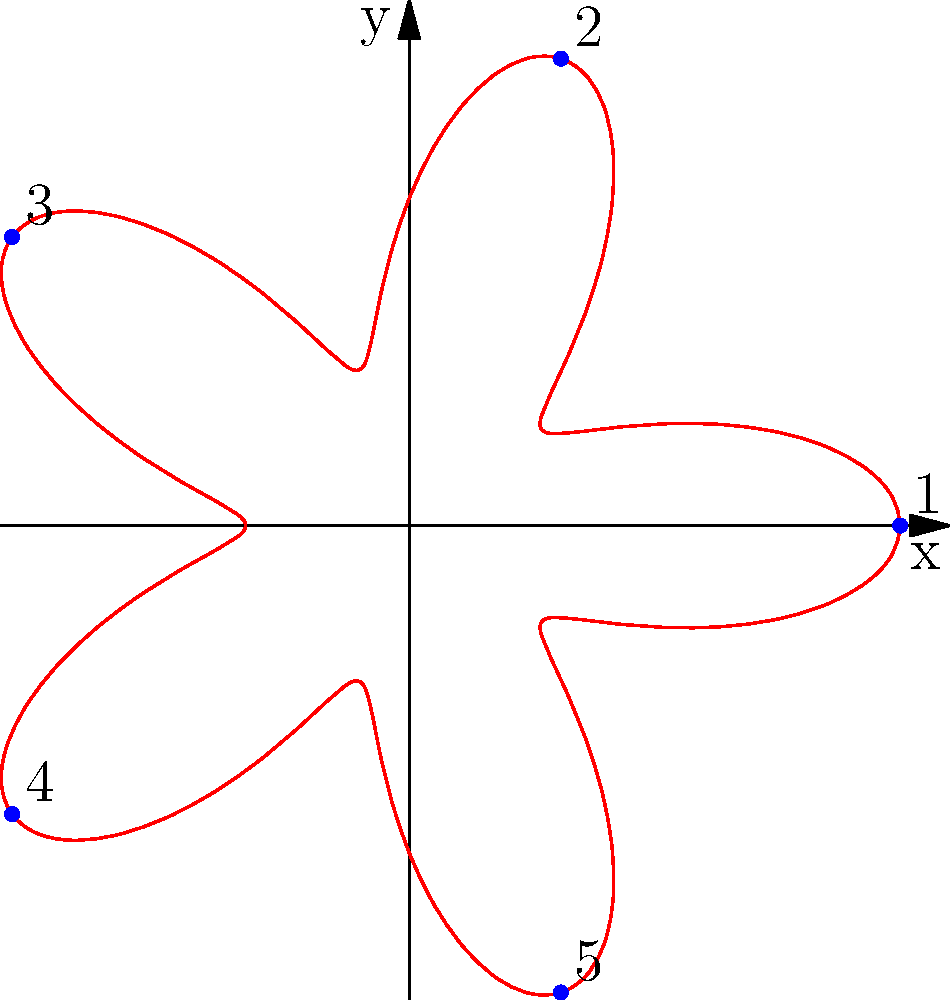The polar rose diagram above represents the distribution of rare book donations across five university departments. Each petal corresponds to a department, and the distance from the center represents the number of books donated. If the equation of this polar rose is $r = 2 + \cos(5\theta)$, which department received the most donations? To determine which department received the most donations, we need to find the maximum value of $r$ in the equation $r = 2 + \cos(5\theta)$.

1. The maximum value of $\cos(5\theta)$ is 1, which occurs when $5\theta = 0, 2\pi, 4\pi,$ etc.

2. When $\cos(5\theta) = 1$, $r = 2 + 1 = 3$, which is the maximum value of $r$.

3. This maximum occurs at $\theta = 0, \frac{2\pi}{5}, \frac{4\pi}{5},$ etc.

4. In the diagram, we can see that the petal pointing directly to the right (along the positive x-axis) is the longest.

5. This petal corresponds to $\theta = 0$, which is labeled as department 1 in the diagram.

Therefore, department 1 received the most donations.
Answer: Department 1 